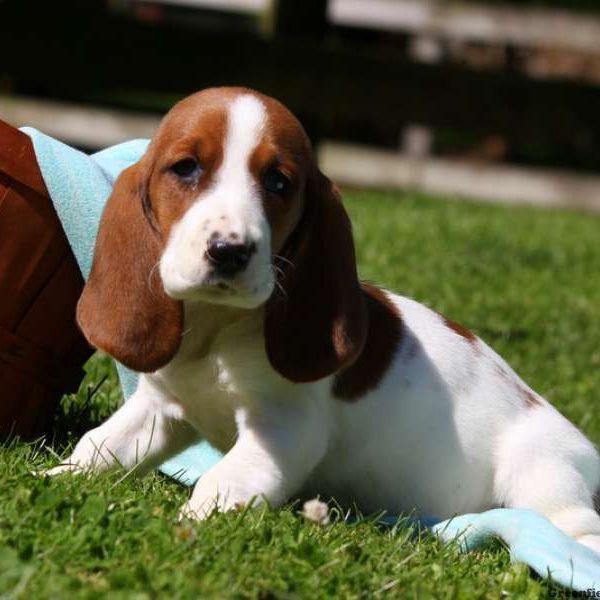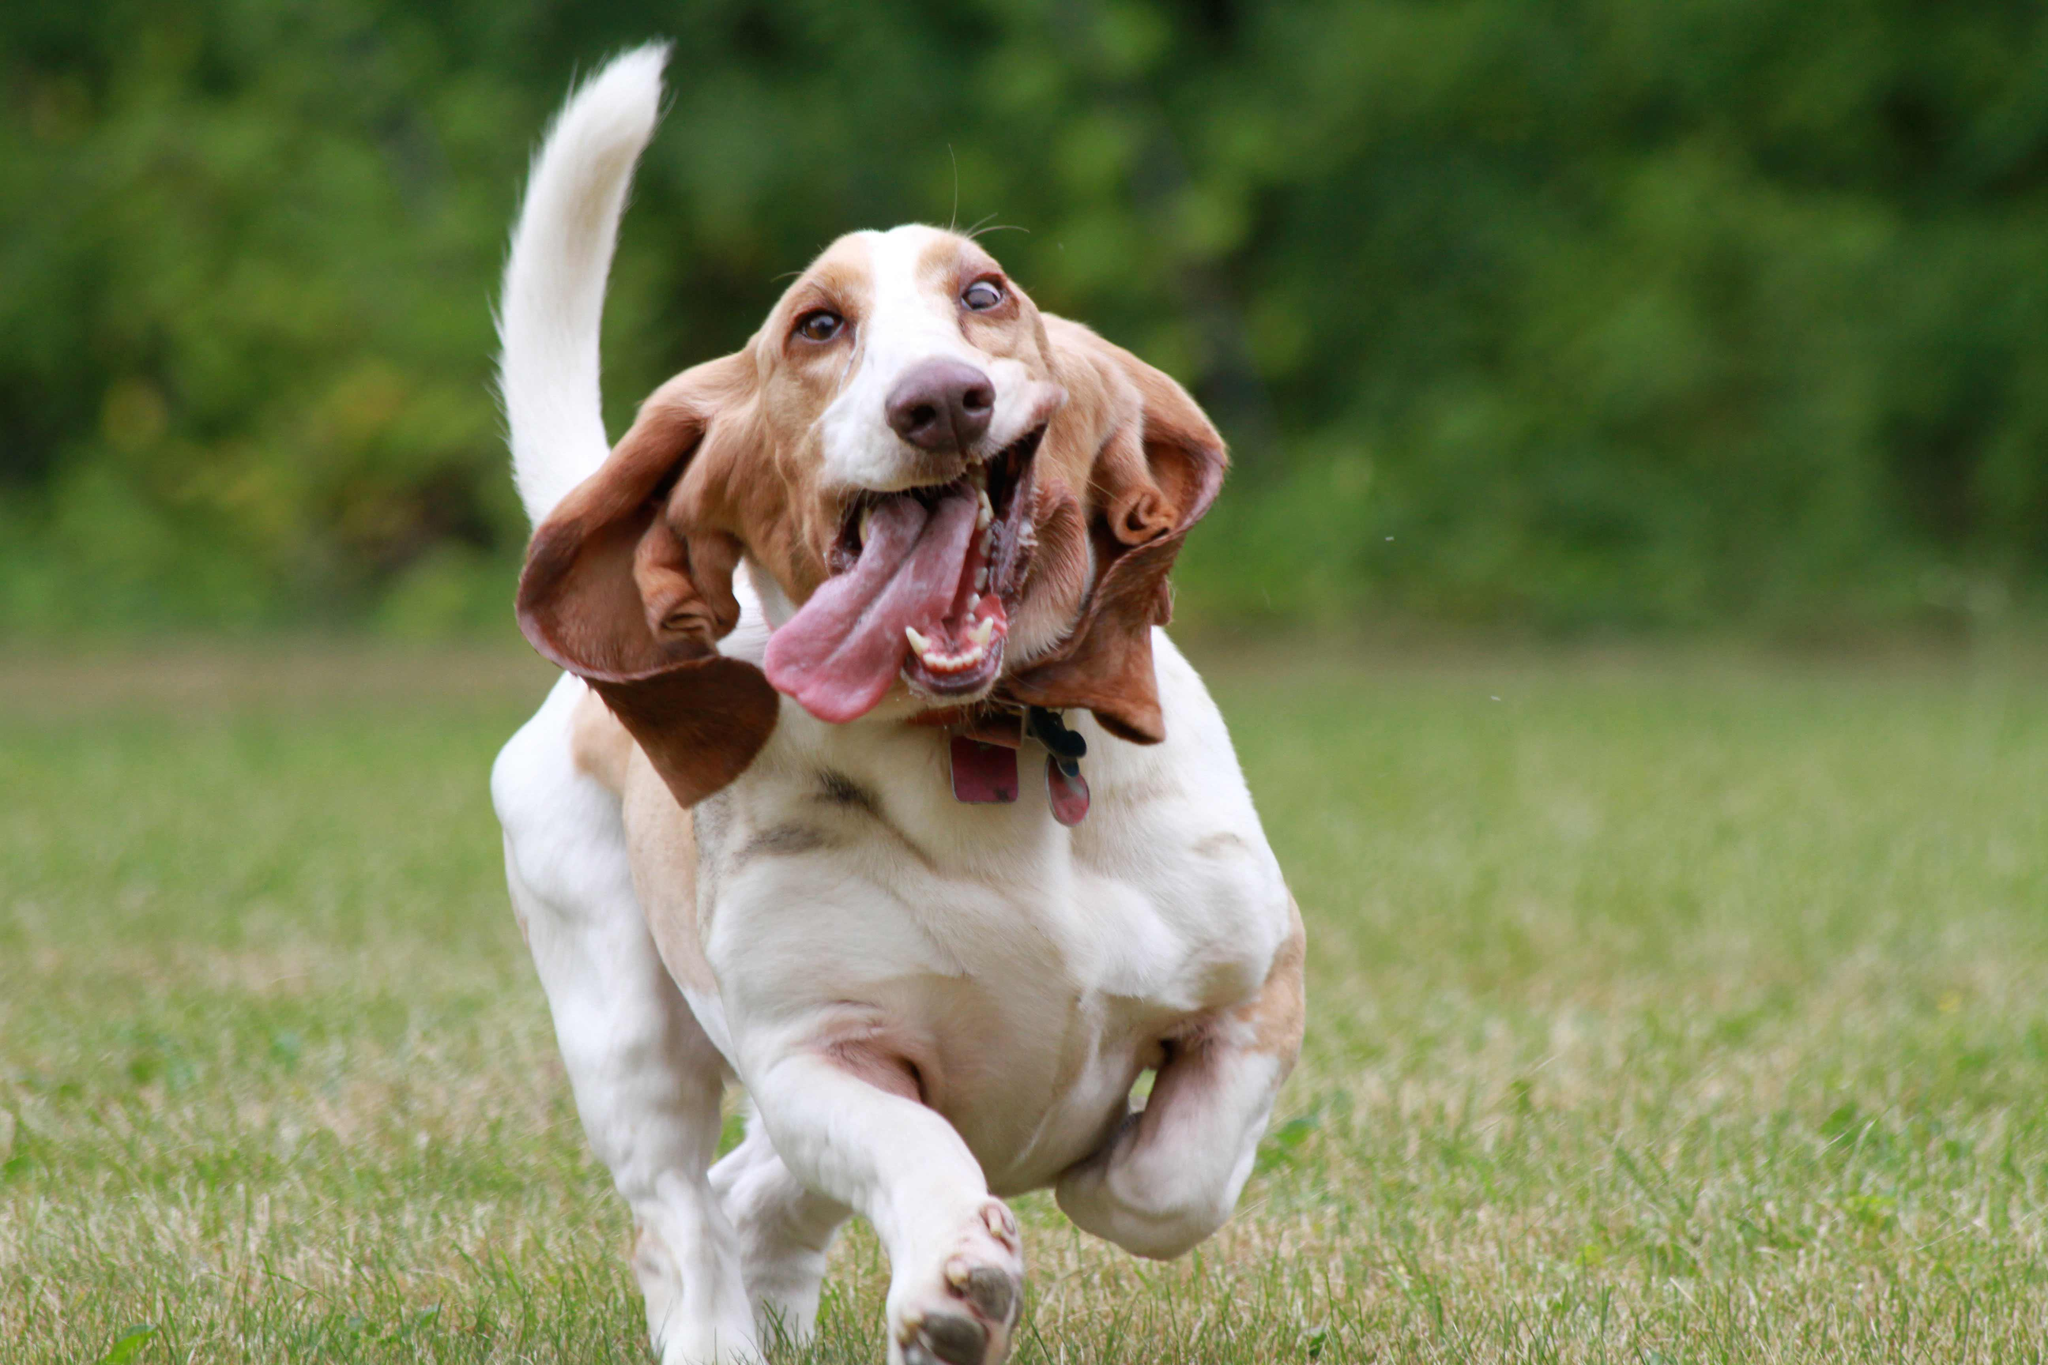The first image is the image on the left, the second image is the image on the right. Evaluate the accuracy of this statement regarding the images: "The left image shows a basset pup on green grass.". Is it true? Answer yes or no. Yes. 